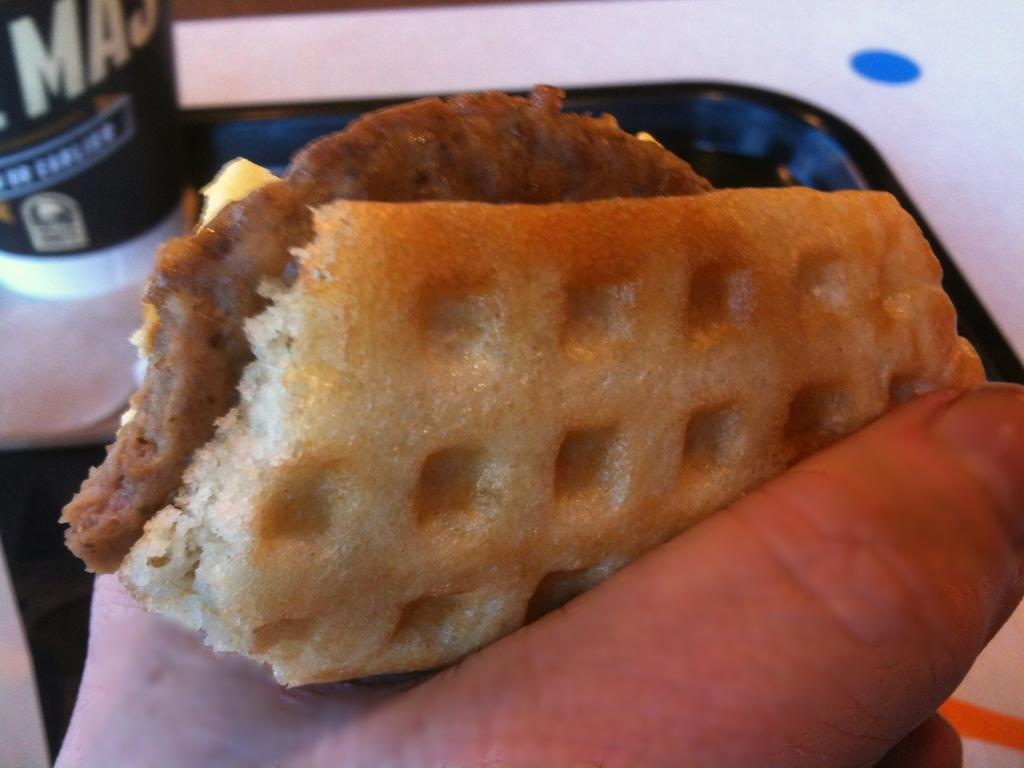What is the person in the image holding? The person is holding food in the image. What color is the tray that is visible in the image? The tray is black in the image. On what surface is the black tray placed? The black tray is on a white surface in the image. What type of quill is the person using to write on the food in the image? There is no quill present in the image, and the person is not writing on the food. 